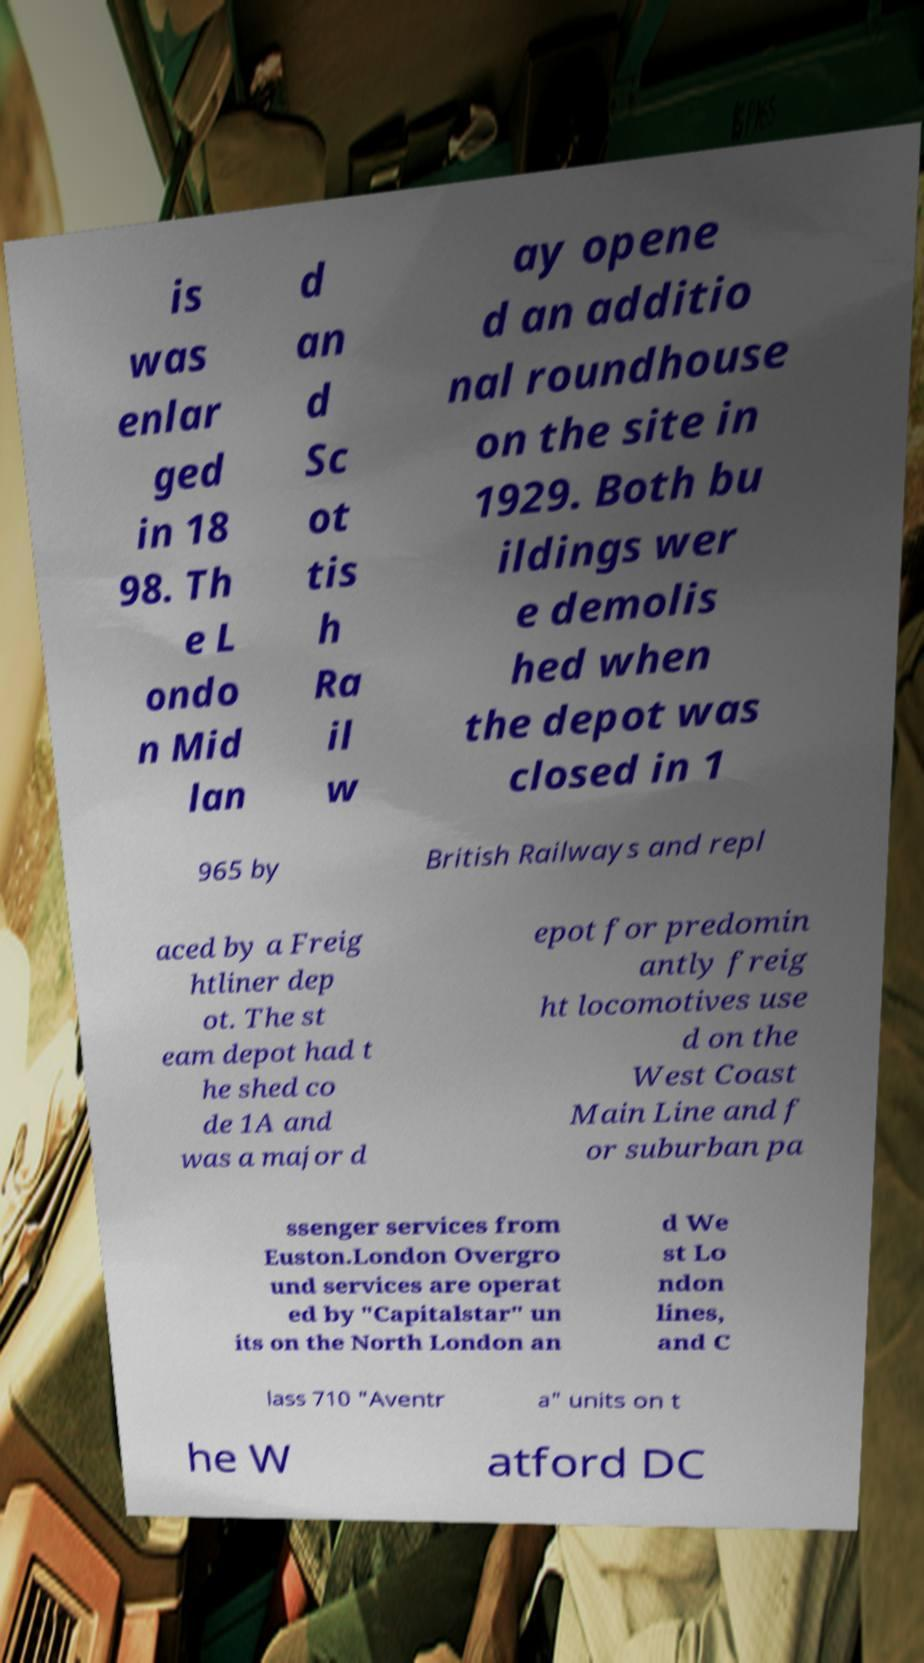What messages or text are displayed in this image? I need them in a readable, typed format. is was enlar ged in 18 98. Th e L ondo n Mid lan d an d Sc ot tis h Ra il w ay opene d an additio nal roundhouse on the site in 1929. Both bu ildings wer e demolis hed when the depot was closed in 1 965 by British Railways and repl aced by a Freig htliner dep ot. The st eam depot had t he shed co de 1A and was a major d epot for predomin antly freig ht locomotives use d on the West Coast Main Line and f or suburban pa ssenger services from Euston.London Overgro und services are operat ed by "Capitalstar" un its on the North London an d We st Lo ndon lines, and C lass 710 "Aventr a" units on t he W atford DC 